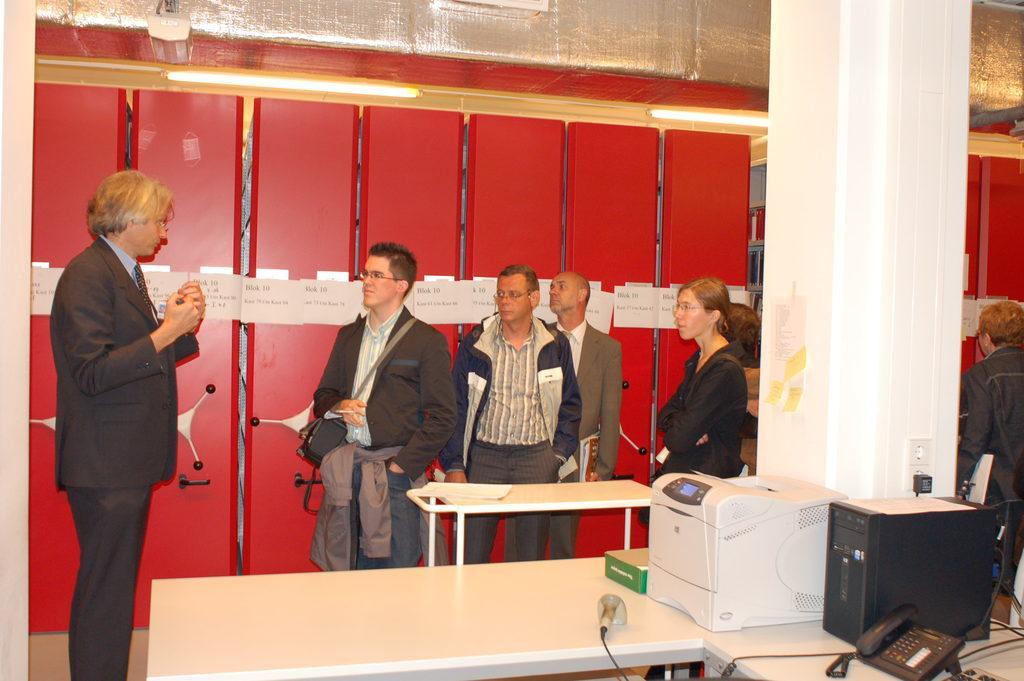Can you describe this image briefly? In this image I see number of people who are standing and there are tables near them, on which there are few equipment, In the background I see the lights on the ceiling. 